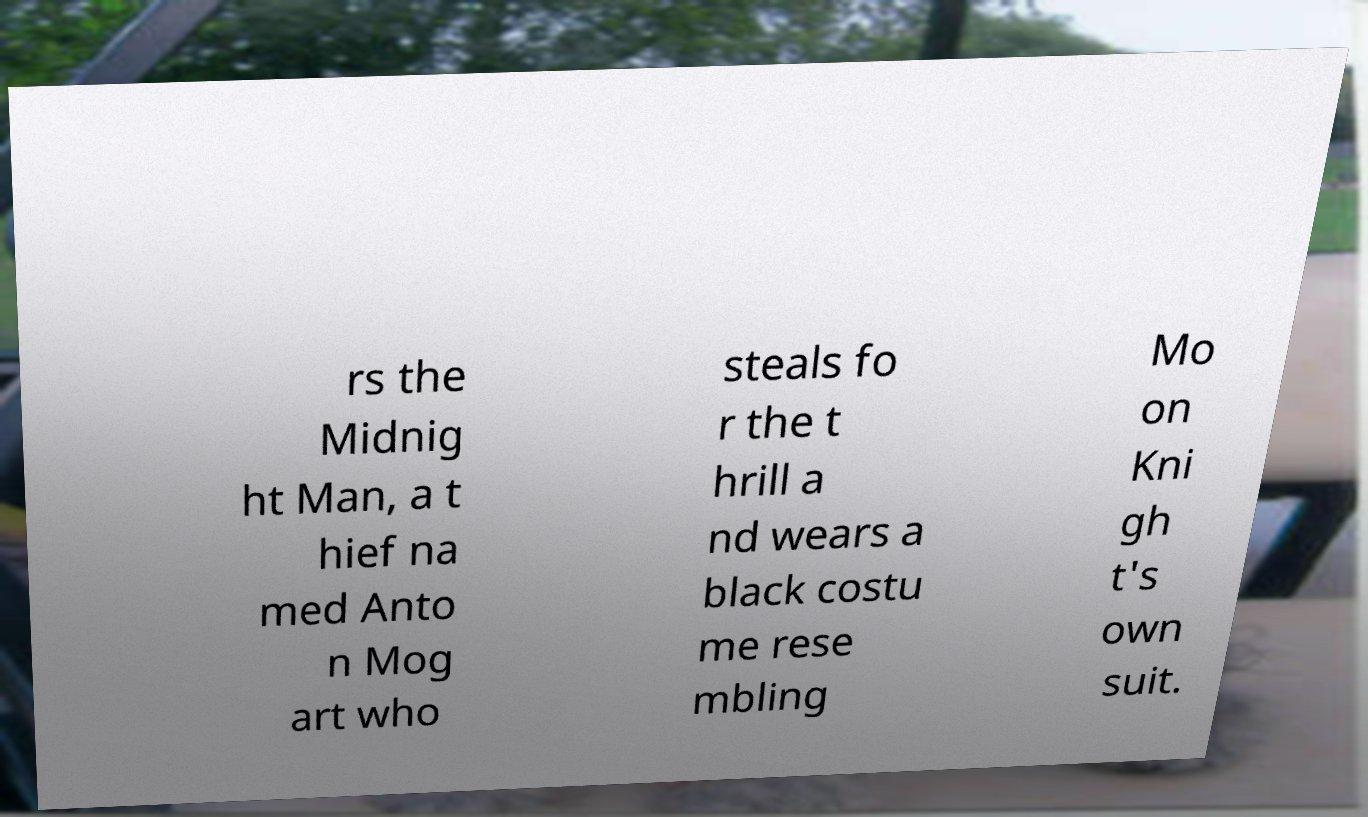Can you read and provide the text displayed in the image?This photo seems to have some interesting text. Can you extract and type it out for me? rs the Midnig ht Man, a t hief na med Anto n Mog art who steals fo r the t hrill a nd wears a black costu me rese mbling Mo on Kni gh t's own suit. 